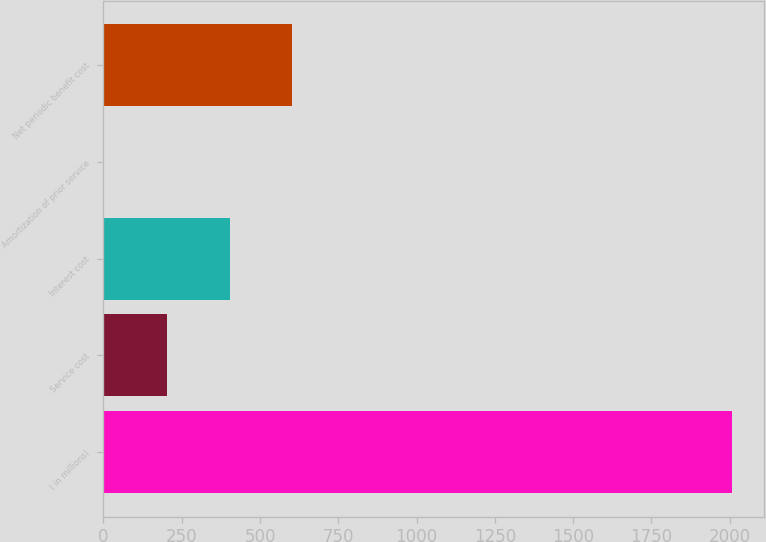<chart> <loc_0><loc_0><loc_500><loc_500><bar_chart><fcel>( in millions)<fcel>Service cost<fcel>Interest cost<fcel>Amortization of prior service<fcel>Net periodic benefit cost<nl><fcel>2009<fcel>201.89<fcel>402.68<fcel>1.1<fcel>603.47<nl></chart> 